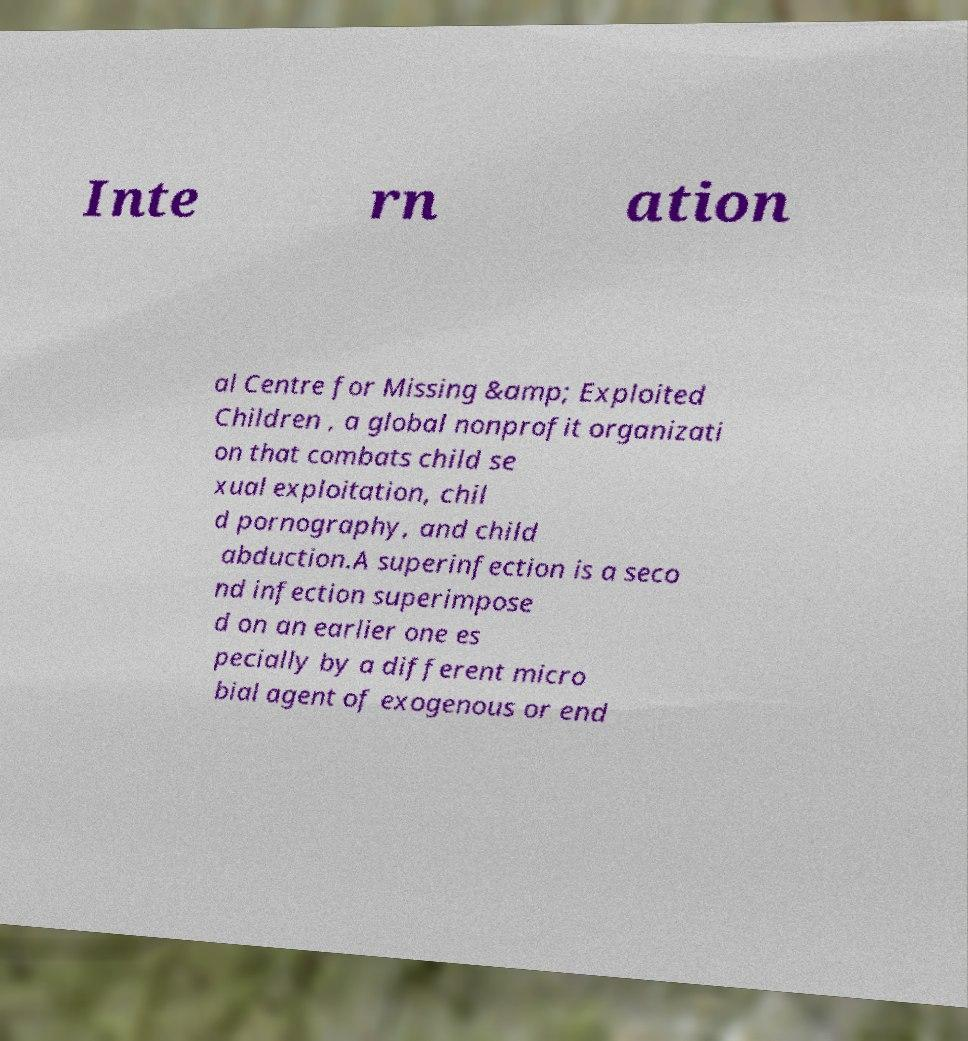For documentation purposes, I need the text within this image transcribed. Could you provide that? Inte rn ation al Centre for Missing &amp; Exploited Children , a global nonprofit organizati on that combats child se xual exploitation, chil d pornography, and child abduction.A superinfection is a seco nd infection superimpose d on an earlier one es pecially by a different micro bial agent of exogenous or end 